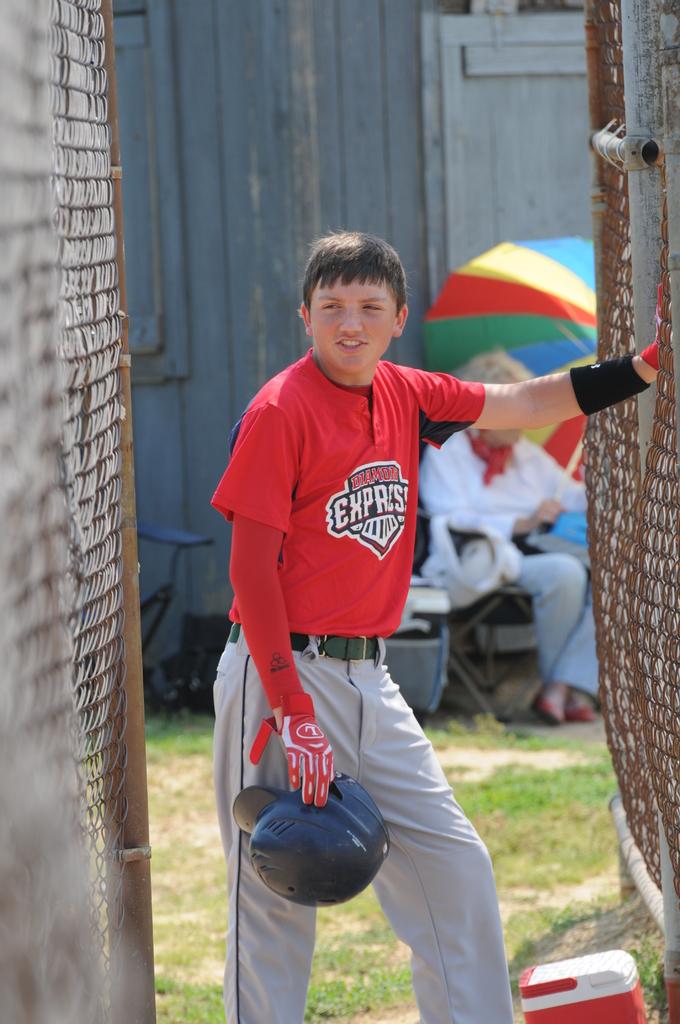What is the team name on the front of the jersey?
Your answer should be compact. Express. 